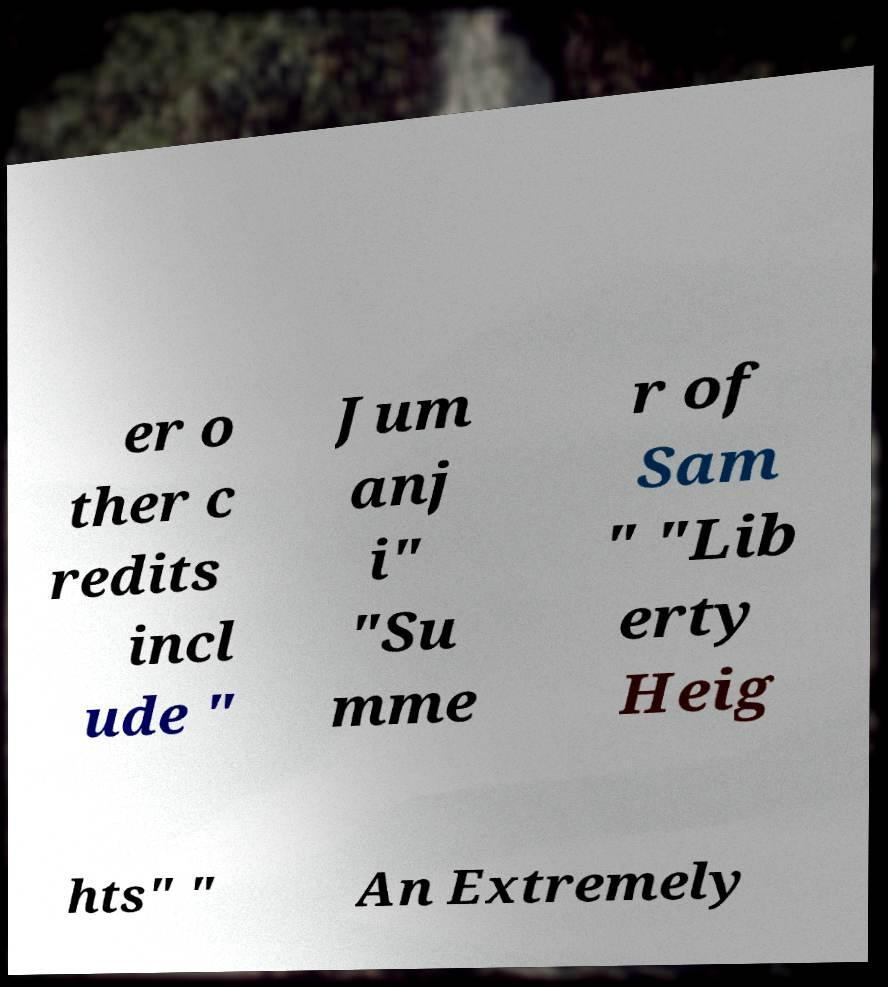Can you accurately transcribe the text from the provided image for me? er o ther c redits incl ude " Jum anj i" "Su mme r of Sam " "Lib erty Heig hts" " An Extremely 